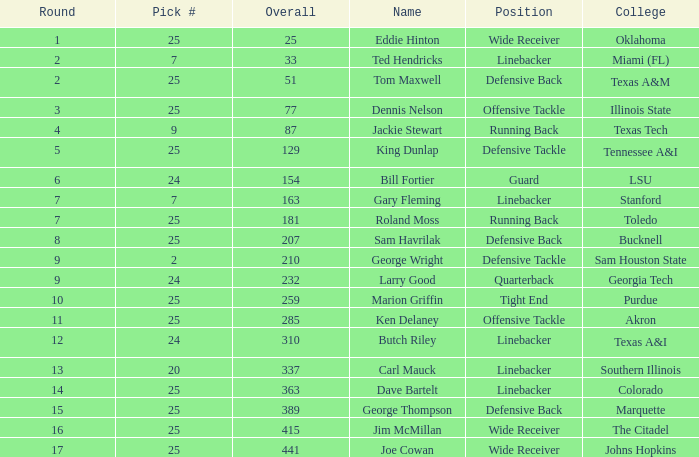College of lsu has how many rounds? 1.0. Could you help me parse every detail presented in this table? {'header': ['Round', 'Pick #', 'Overall', 'Name', 'Position', 'College'], 'rows': [['1', '25', '25', 'Eddie Hinton', 'Wide Receiver', 'Oklahoma'], ['2', '7', '33', 'Ted Hendricks', 'Linebacker', 'Miami (FL)'], ['2', '25', '51', 'Tom Maxwell', 'Defensive Back', 'Texas A&M'], ['3', '25', '77', 'Dennis Nelson', 'Offensive Tackle', 'Illinois State'], ['4', '9', '87', 'Jackie Stewart', 'Running Back', 'Texas Tech'], ['5', '25', '129', 'King Dunlap', 'Defensive Tackle', 'Tennessee A&I'], ['6', '24', '154', 'Bill Fortier', 'Guard', 'LSU'], ['7', '7', '163', 'Gary Fleming', 'Linebacker', 'Stanford'], ['7', '25', '181', 'Roland Moss', 'Running Back', 'Toledo'], ['8', '25', '207', 'Sam Havrilak', 'Defensive Back', 'Bucknell'], ['9', '2', '210', 'George Wright', 'Defensive Tackle', 'Sam Houston State'], ['9', '24', '232', 'Larry Good', 'Quarterback', 'Georgia Tech'], ['10', '25', '259', 'Marion Griffin', 'Tight End', 'Purdue'], ['11', '25', '285', 'Ken Delaney', 'Offensive Tackle', 'Akron'], ['12', '24', '310', 'Butch Riley', 'Linebacker', 'Texas A&I'], ['13', '20', '337', 'Carl Mauck', 'Linebacker', 'Southern Illinois'], ['14', '25', '363', 'Dave Bartelt', 'Linebacker', 'Colorado'], ['15', '25', '389', 'George Thompson', 'Defensive Back', 'Marquette'], ['16', '25', '415', 'Jim McMillan', 'Wide Receiver', 'The Citadel'], ['17', '25', '441', 'Joe Cowan', 'Wide Receiver', 'Johns Hopkins']]} 